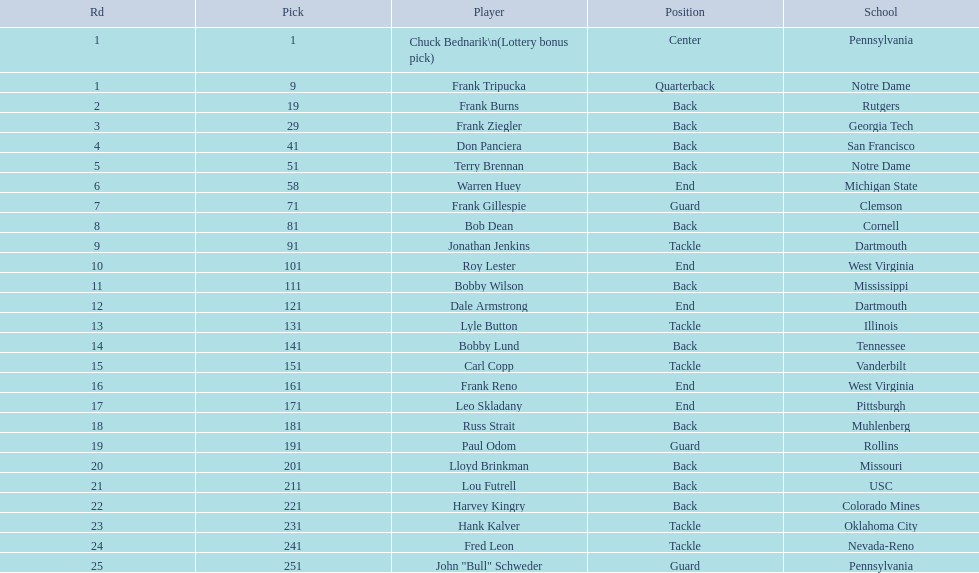What is the greatest rd figure? 25. 